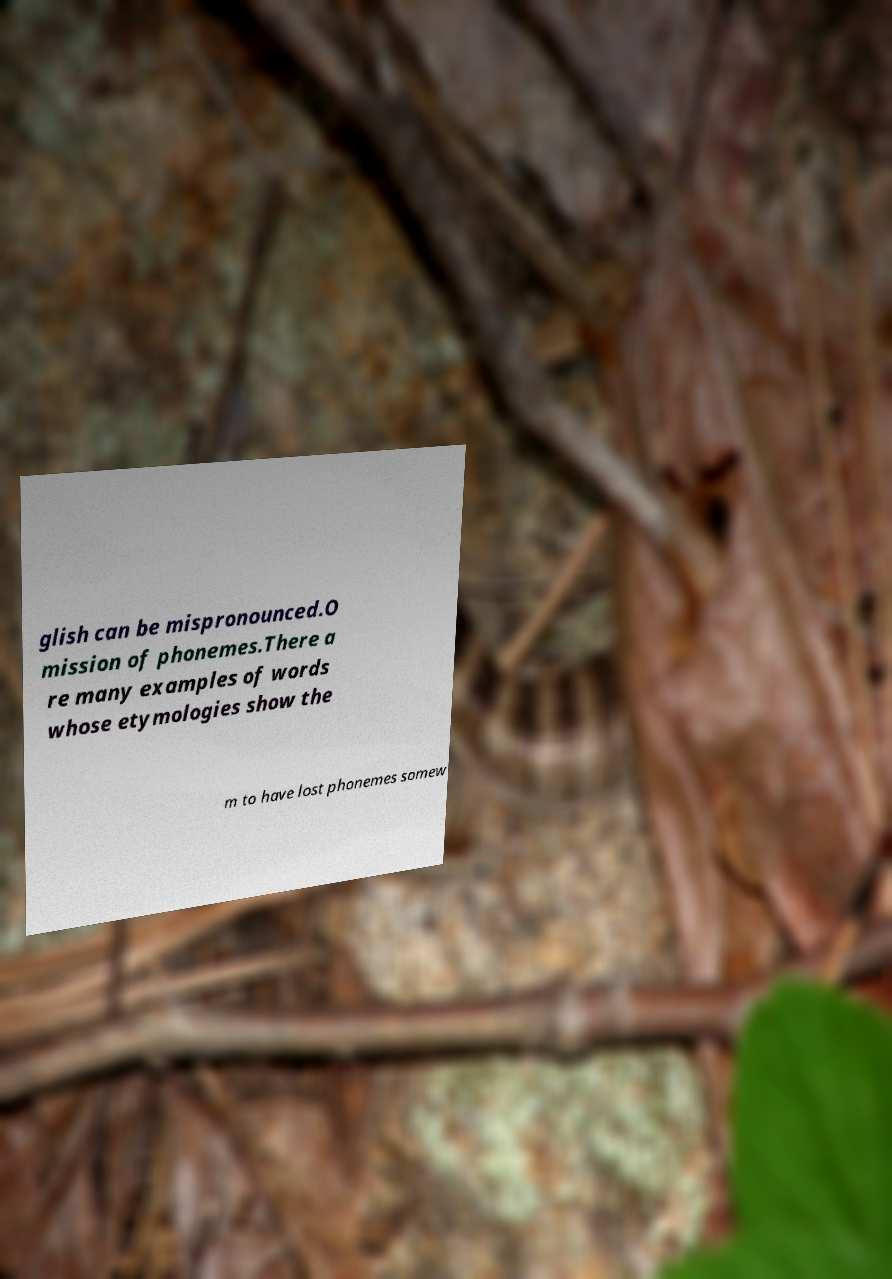There's text embedded in this image that I need extracted. Can you transcribe it verbatim? glish can be mispronounced.O mission of phonemes.There a re many examples of words whose etymologies show the m to have lost phonemes somew 